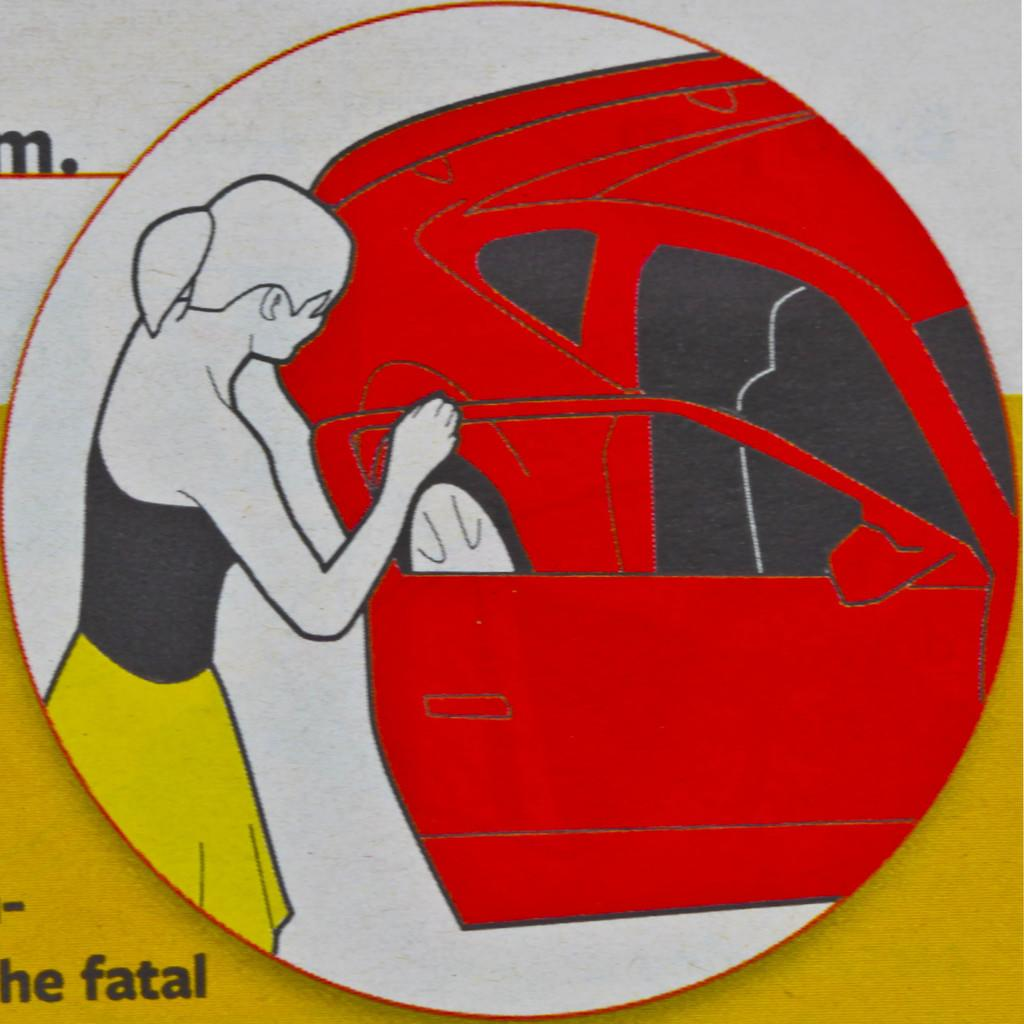What is the main subject of the painting in the image? The painting depicts a car. Are there any other elements in the painting besides the car? Yes, the painting also includes a woman. Is there any text present in the image? Yes, there is text present in the image. Can you tell me how many volleyballs are in the painting? There are no volleyballs present in the painting; it features a car and a woman. What type of thrill can be experienced by following the trail in the painting? There is no trail present in the painting; it only features a car and a woman. 